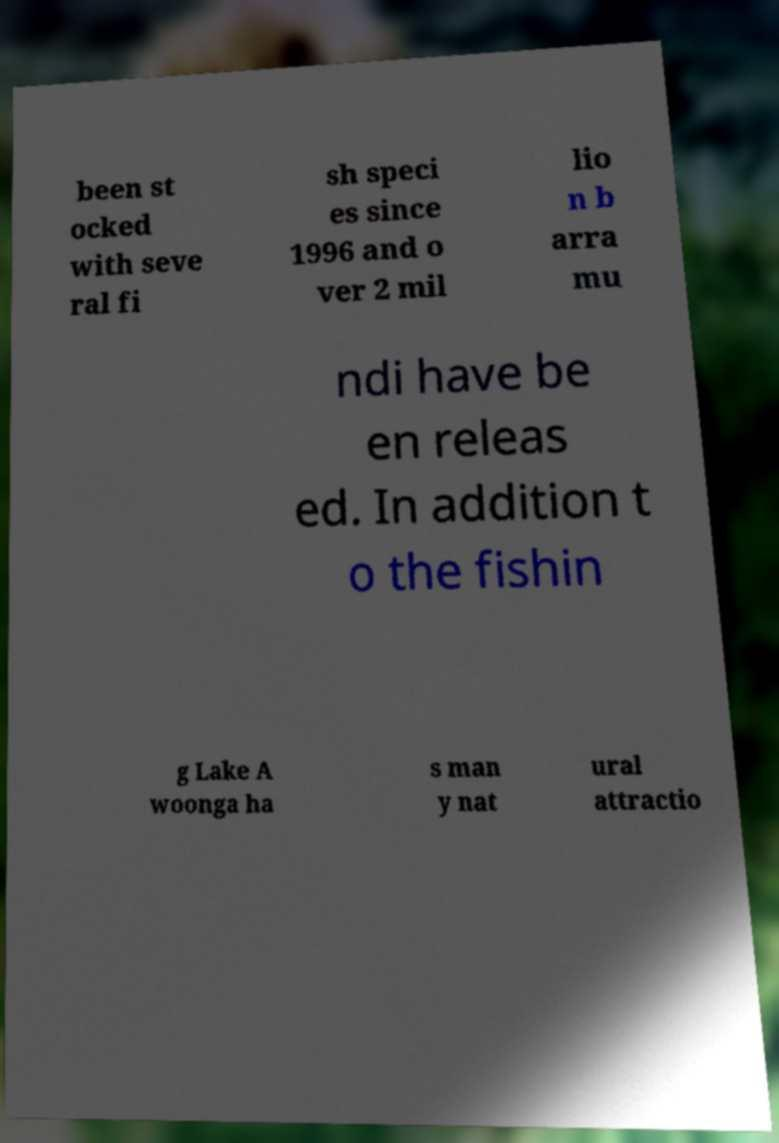Please read and relay the text visible in this image. What does it say? been st ocked with seve ral fi sh speci es since 1996 and o ver 2 mil lio n b arra mu ndi have be en releas ed. In addition t o the fishin g Lake A woonga ha s man y nat ural attractio 